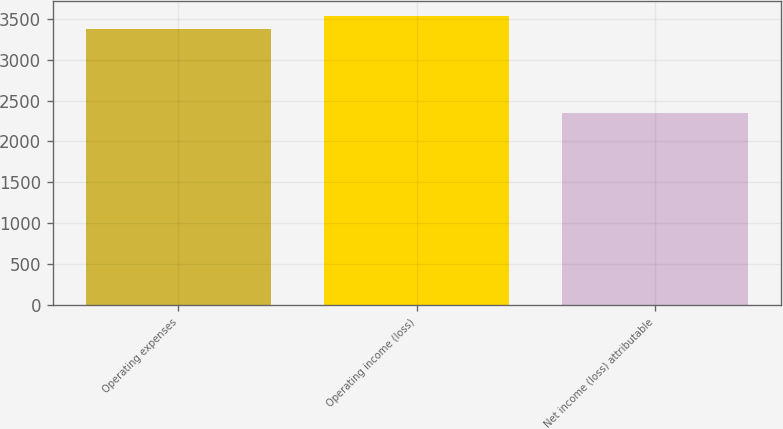Convert chart to OTSL. <chart><loc_0><loc_0><loc_500><loc_500><bar_chart><fcel>Operating expenses<fcel>Operating income (loss)<fcel>Net income (loss) attributable<nl><fcel>3373<fcel>3538<fcel>2353<nl></chart> 